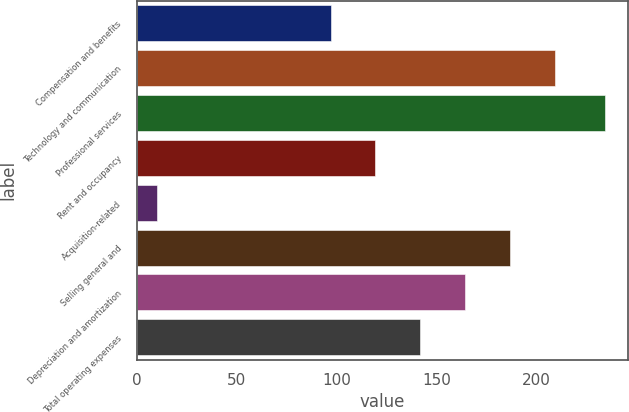Convert chart to OTSL. <chart><loc_0><loc_0><loc_500><loc_500><bar_chart><fcel>Compensation and benefits<fcel>Technology and communication<fcel>Professional services<fcel>Rent and occupancy<fcel>Acquisition-related<fcel>Selling general and<fcel>Depreciation and amortization<fcel>Total operating expenses<nl><fcel>97<fcel>209<fcel>234<fcel>119.4<fcel>10<fcel>186.6<fcel>164.2<fcel>141.8<nl></chart> 